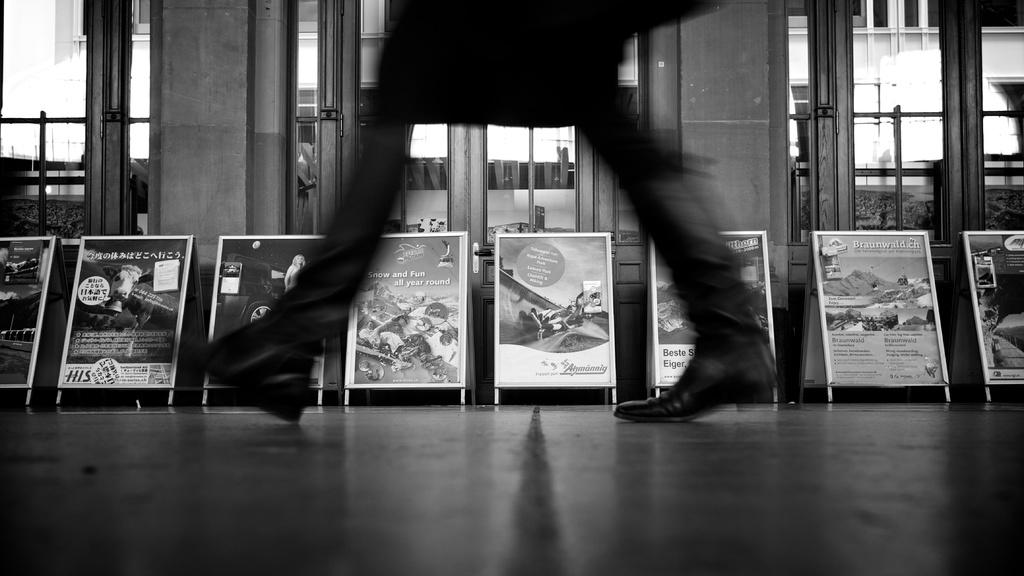What is the color scheme of the image? The image is black and white. What can be seen attached to boards in the image? There are posters attached to boards in the image. What type of building is visible in the image? There is a building with glass doors in the image. Whose legs are visible in the image? A person's legs are visible in the image. Can you see any corn growing in the image? There is no corn visible in the image. What type of mask is the person wearing in the image? There is no person wearing a mask in the image; only their legs are visible. 